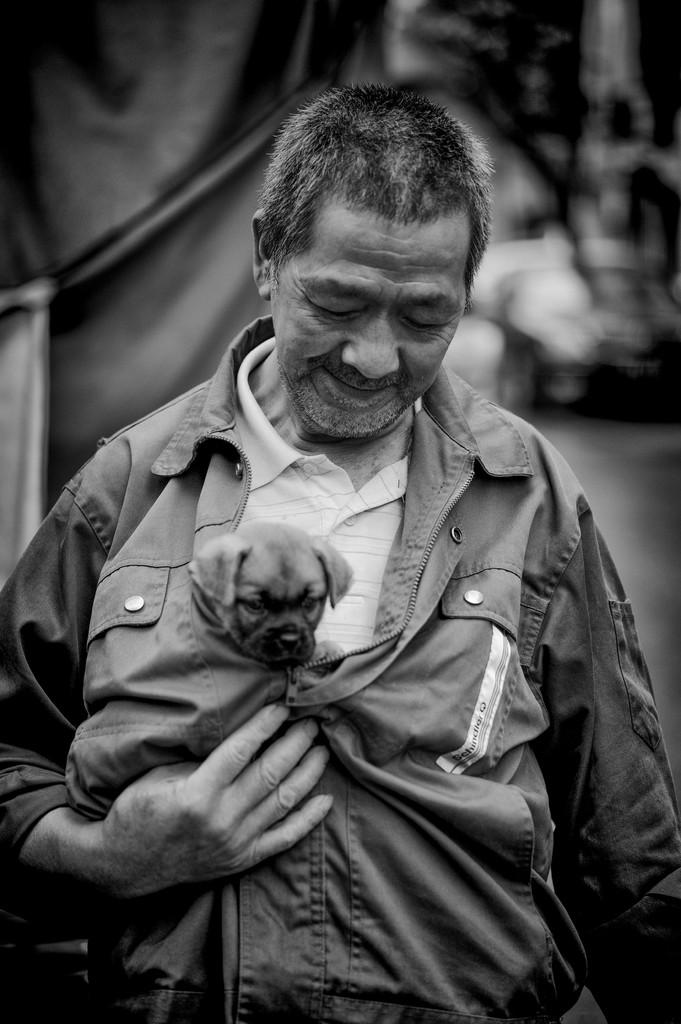What is the main subject of the image? There is a person standing in the center of the image. What is the person doing in the image? The person is smiling and holding a dog. What can be seen in the background of the image? There is a sheet in the background of the image. What type of sheet is the person using to express their desire in the image? There is no indication in the image that the person is expressing any desires, nor is there any sheet being used for that purpose. 